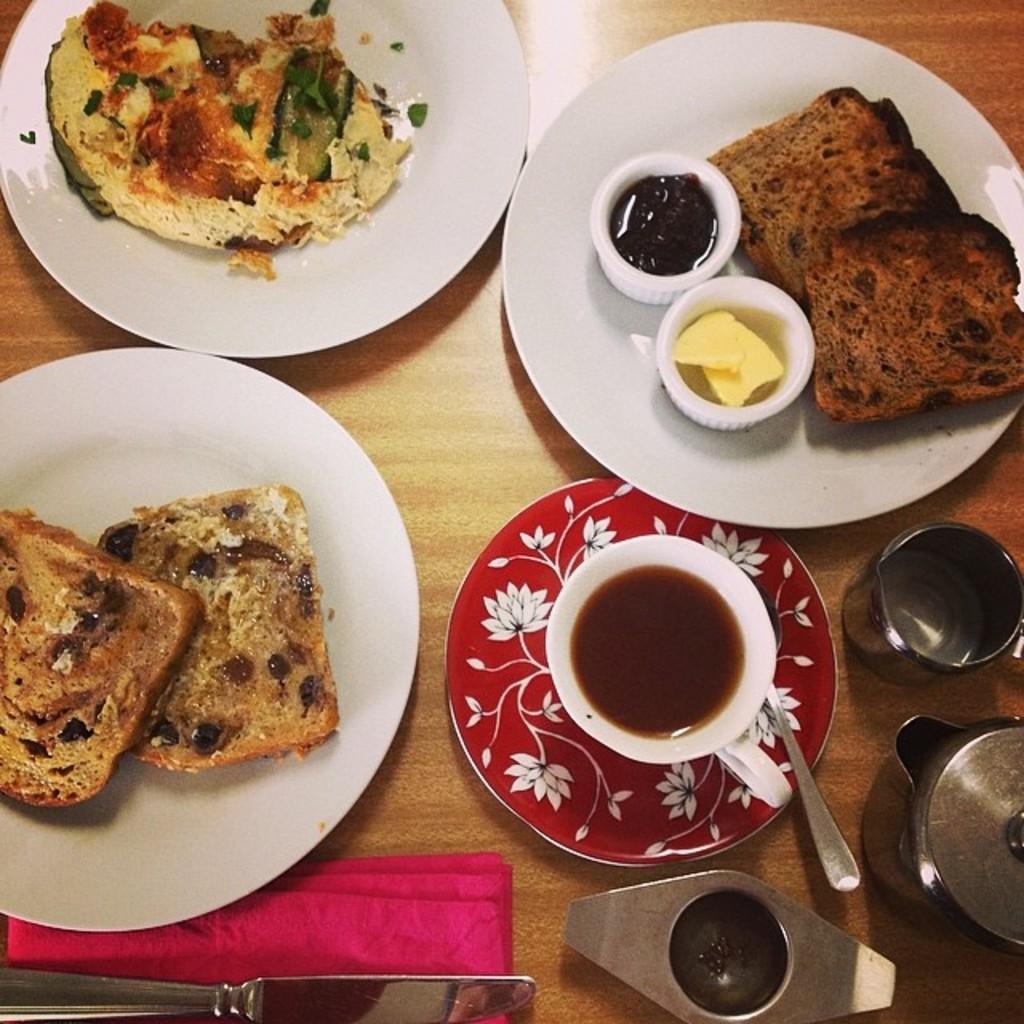Please provide a concise description of this image. In this image we can see a table, on the table there are some plates, bowls, cups, napkin and a spoon, in the plates there is some food and in the cups we can see the ice cream and tea. 